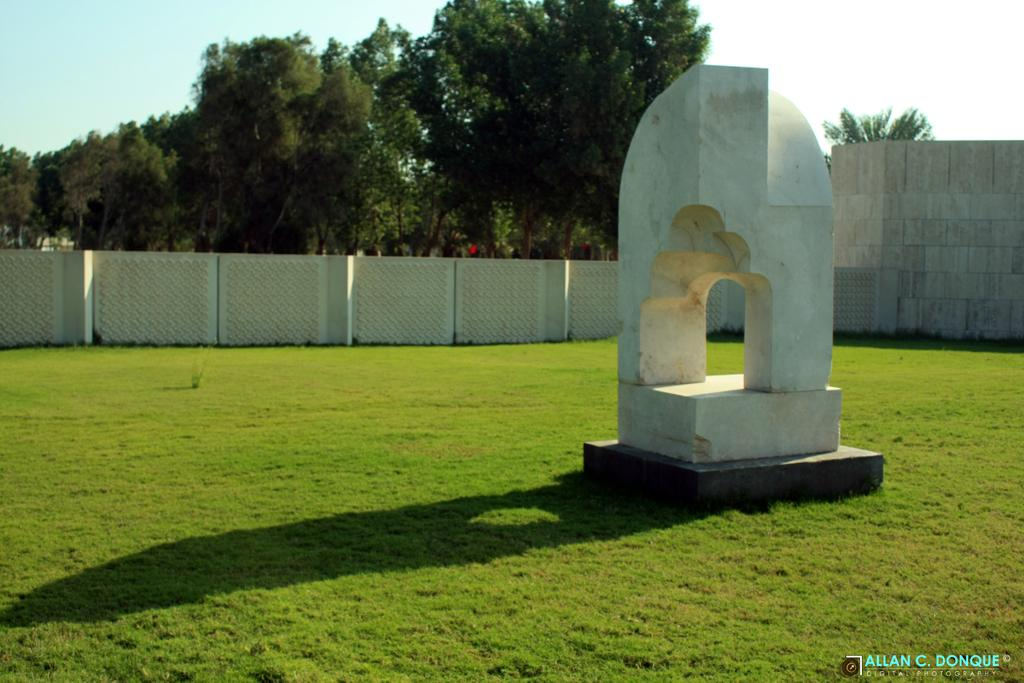What structure can be seen in the grass in the image? There is an arch in the grass in the image. What type of barrier is present from left to right in the image? There is fencing from left to right in the image. What can be seen in the background of the image? Trees are visible in the background of the image. Where is the coil located in the image? There is no coil present in the image. What type of carriage can be seen in the background of the image? There is no carriage present in the image. 